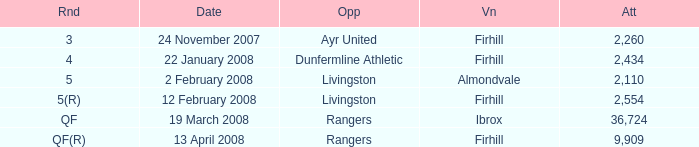What day was the game held at Firhill against AYR United? 24 November 2007. 